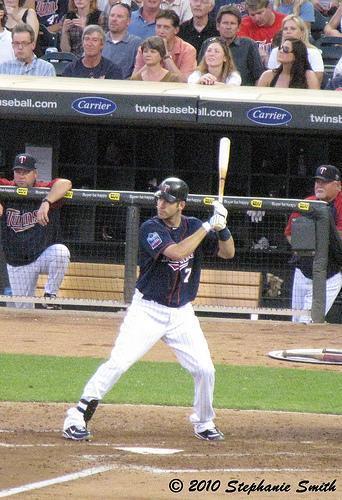How many players are there on the field?
Give a very brief answer. 1. 